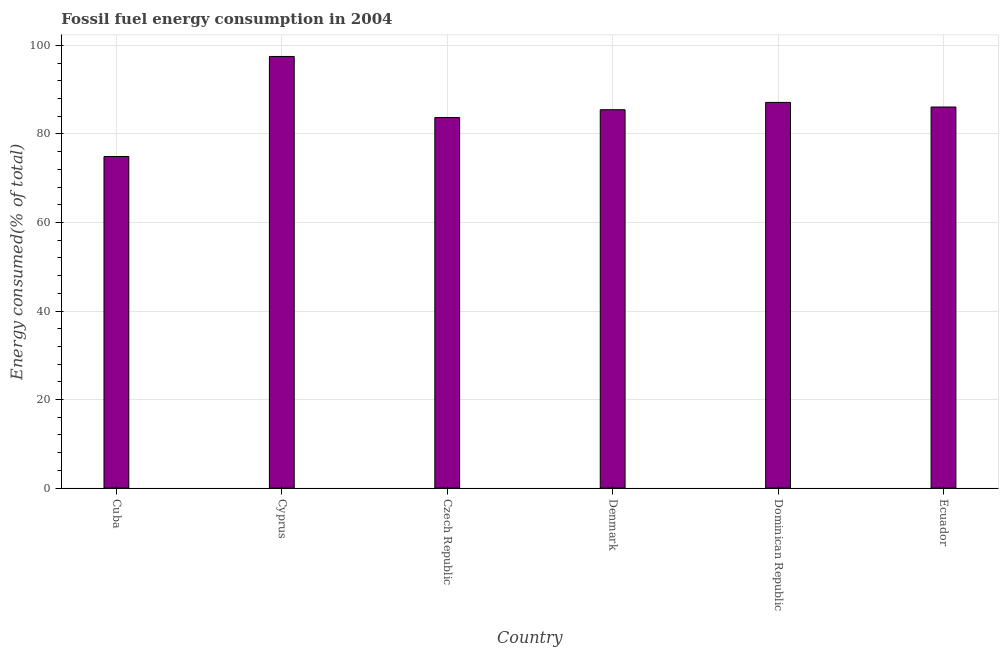Does the graph contain any zero values?
Your response must be concise. No. Does the graph contain grids?
Offer a very short reply. Yes. What is the title of the graph?
Make the answer very short. Fossil fuel energy consumption in 2004. What is the label or title of the Y-axis?
Keep it short and to the point. Energy consumed(% of total). What is the fossil fuel energy consumption in Denmark?
Keep it short and to the point. 85.47. Across all countries, what is the maximum fossil fuel energy consumption?
Ensure brevity in your answer.  97.5. Across all countries, what is the minimum fossil fuel energy consumption?
Make the answer very short. 74.9. In which country was the fossil fuel energy consumption maximum?
Offer a very short reply. Cyprus. In which country was the fossil fuel energy consumption minimum?
Your response must be concise. Cuba. What is the sum of the fossil fuel energy consumption?
Provide a short and direct response. 514.77. What is the difference between the fossil fuel energy consumption in Cyprus and Dominican Republic?
Provide a succinct answer. 10.38. What is the average fossil fuel energy consumption per country?
Offer a very short reply. 85.8. What is the median fossil fuel energy consumption?
Provide a succinct answer. 85.77. In how many countries, is the fossil fuel energy consumption greater than 72 %?
Offer a terse response. 6. What is the difference between the highest and the second highest fossil fuel energy consumption?
Give a very brief answer. 10.38. Is the sum of the fossil fuel energy consumption in Denmark and Ecuador greater than the maximum fossil fuel energy consumption across all countries?
Offer a terse response. Yes. What is the difference between the highest and the lowest fossil fuel energy consumption?
Give a very brief answer. 22.6. How many bars are there?
Make the answer very short. 6. What is the difference between two consecutive major ticks on the Y-axis?
Offer a very short reply. 20. What is the Energy consumed(% of total) in Cuba?
Your response must be concise. 74.9. What is the Energy consumed(% of total) of Cyprus?
Give a very brief answer. 97.5. What is the Energy consumed(% of total) of Czech Republic?
Give a very brief answer. 83.7. What is the Energy consumed(% of total) in Denmark?
Keep it short and to the point. 85.47. What is the Energy consumed(% of total) in Dominican Republic?
Provide a succinct answer. 87.12. What is the Energy consumed(% of total) of Ecuador?
Provide a succinct answer. 86.08. What is the difference between the Energy consumed(% of total) in Cuba and Cyprus?
Make the answer very short. -22.6. What is the difference between the Energy consumed(% of total) in Cuba and Czech Republic?
Make the answer very short. -8.8. What is the difference between the Energy consumed(% of total) in Cuba and Denmark?
Your answer should be compact. -10.56. What is the difference between the Energy consumed(% of total) in Cuba and Dominican Republic?
Provide a succinct answer. -12.22. What is the difference between the Energy consumed(% of total) in Cuba and Ecuador?
Your answer should be compact. -11.17. What is the difference between the Energy consumed(% of total) in Cyprus and Czech Republic?
Offer a terse response. 13.8. What is the difference between the Energy consumed(% of total) in Cyprus and Denmark?
Ensure brevity in your answer.  12.03. What is the difference between the Energy consumed(% of total) in Cyprus and Dominican Republic?
Keep it short and to the point. 10.38. What is the difference between the Energy consumed(% of total) in Cyprus and Ecuador?
Your answer should be compact. 11.42. What is the difference between the Energy consumed(% of total) in Czech Republic and Denmark?
Your answer should be very brief. -1.76. What is the difference between the Energy consumed(% of total) in Czech Republic and Dominican Republic?
Your response must be concise. -3.42. What is the difference between the Energy consumed(% of total) in Czech Republic and Ecuador?
Keep it short and to the point. -2.38. What is the difference between the Energy consumed(% of total) in Denmark and Dominican Republic?
Provide a short and direct response. -1.66. What is the difference between the Energy consumed(% of total) in Denmark and Ecuador?
Offer a very short reply. -0.61. What is the difference between the Energy consumed(% of total) in Dominican Republic and Ecuador?
Give a very brief answer. 1.04. What is the ratio of the Energy consumed(% of total) in Cuba to that in Cyprus?
Provide a succinct answer. 0.77. What is the ratio of the Energy consumed(% of total) in Cuba to that in Czech Republic?
Keep it short and to the point. 0.9. What is the ratio of the Energy consumed(% of total) in Cuba to that in Denmark?
Ensure brevity in your answer.  0.88. What is the ratio of the Energy consumed(% of total) in Cuba to that in Dominican Republic?
Your answer should be very brief. 0.86. What is the ratio of the Energy consumed(% of total) in Cuba to that in Ecuador?
Ensure brevity in your answer.  0.87. What is the ratio of the Energy consumed(% of total) in Cyprus to that in Czech Republic?
Offer a very short reply. 1.17. What is the ratio of the Energy consumed(% of total) in Cyprus to that in Denmark?
Keep it short and to the point. 1.14. What is the ratio of the Energy consumed(% of total) in Cyprus to that in Dominican Republic?
Make the answer very short. 1.12. What is the ratio of the Energy consumed(% of total) in Cyprus to that in Ecuador?
Provide a short and direct response. 1.13. What is the ratio of the Energy consumed(% of total) in Czech Republic to that in Denmark?
Your answer should be very brief. 0.98. What is the ratio of the Energy consumed(% of total) in Denmark to that in Ecuador?
Offer a very short reply. 0.99. What is the ratio of the Energy consumed(% of total) in Dominican Republic to that in Ecuador?
Your response must be concise. 1.01. 